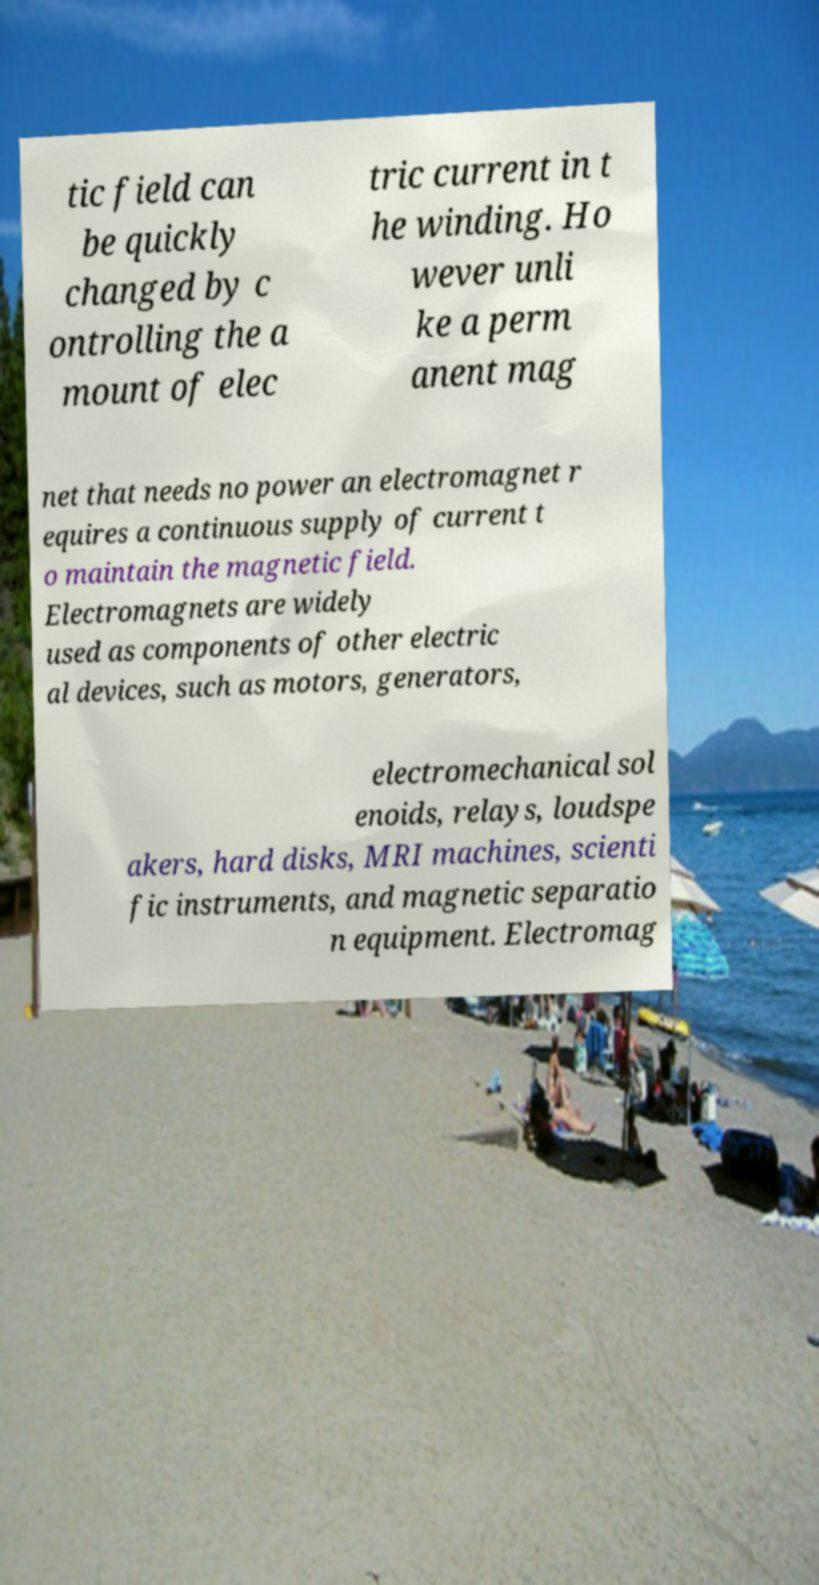Could you extract and type out the text from this image? tic field can be quickly changed by c ontrolling the a mount of elec tric current in t he winding. Ho wever unli ke a perm anent mag net that needs no power an electromagnet r equires a continuous supply of current t o maintain the magnetic field. Electromagnets are widely used as components of other electric al devices, such as motors, generators, electromechanical sol enoids, relays, loudspe akers, hard disks, MRI machines, scienti fic instruments, and magnetic separatio n equipment. Electromag 